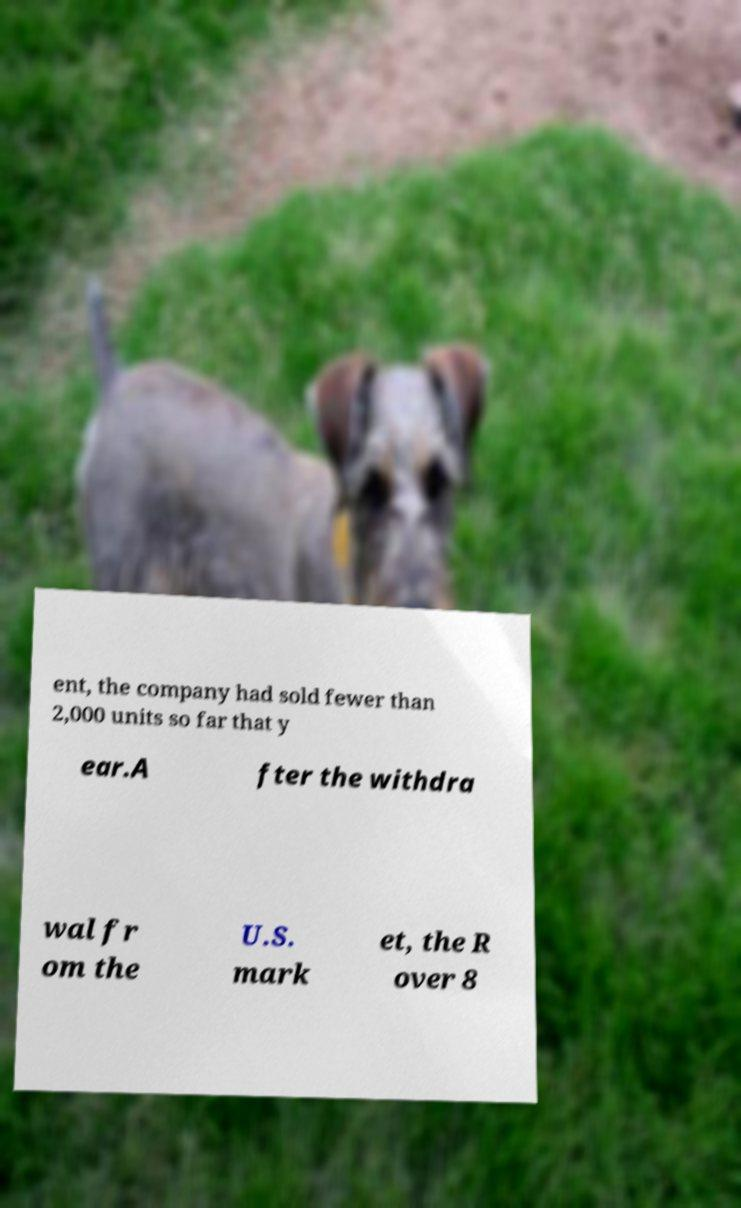Can you read and provide the text displayed in the image?This photo seems to have some interesting text. Can you extract and type it out for me? ent, the company had sold fewer than 2,000 units so far that y ear.A fter the withdra wal fr om the U.S. mark et, the R over 8 